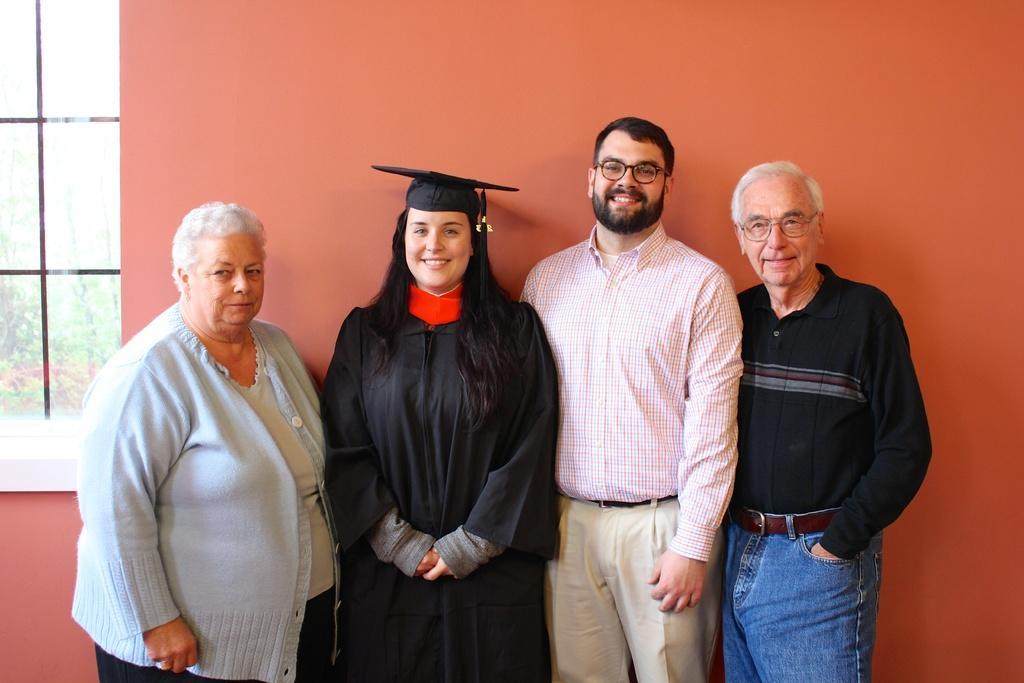In one or two sentences, can you explain what this image depicts? In the center of the image we can see four people are standing and smiling and a lady is wearing a graduation coat, hat. In the background of the image we can see the wall. On the left side of the image we can see a window. Through the window we can see the trees. 